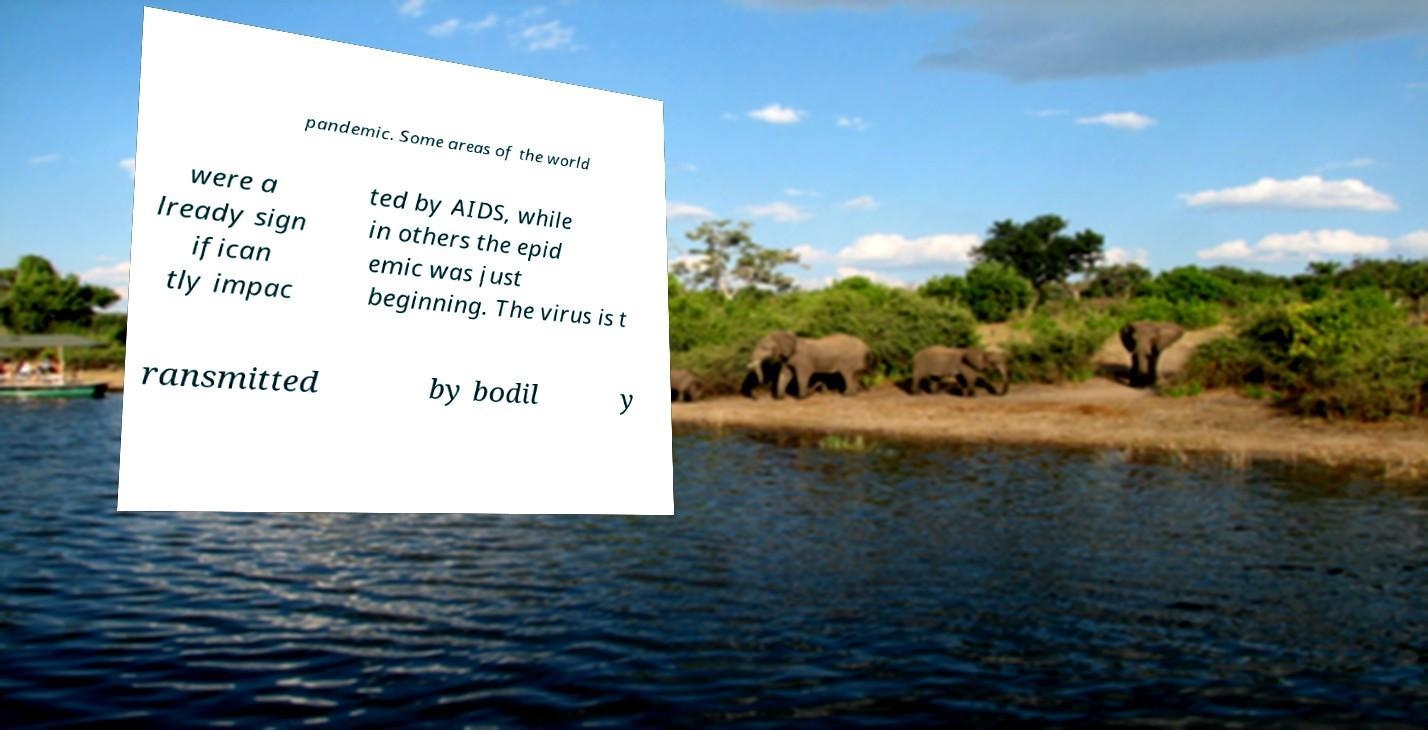Could you assist in decoding the text presented in this image and type it out clearly? pandemic. Some areas of the world were a lready sign ifican tly impac ted by AIDS, while in others the epid emic was just beginning. The virus is t ransmitted by bodil y 